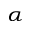<formula> <loc_0><loc_0><loc_500><loc_500>_ { \alpha }</formula> 